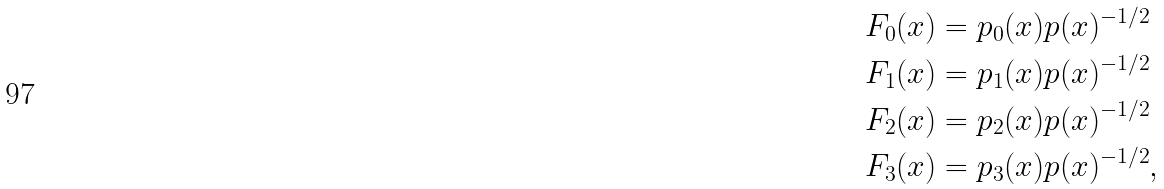<formula> <loc_0><loc_0><loc_500><loc_500>F _ { 0 } ( x ) & = p _ { 0 } ( x ) p ( x ) ^ { - 1 / 2 } \\ F _ { 1 } ( x ) & = p _ { 1 } ( x ) p ( x ) ^ { - 1 / 2 } \\ F _ { 2 } ( x ) & = p _ { 2 } ( x ) p ( x ) ^ { - 1 / 2 } \\ F _ { 3 } ( x ) & = p _ { 3 } ( x ) p ( x ) ^ { - 1 / 2 } ,</formula> 